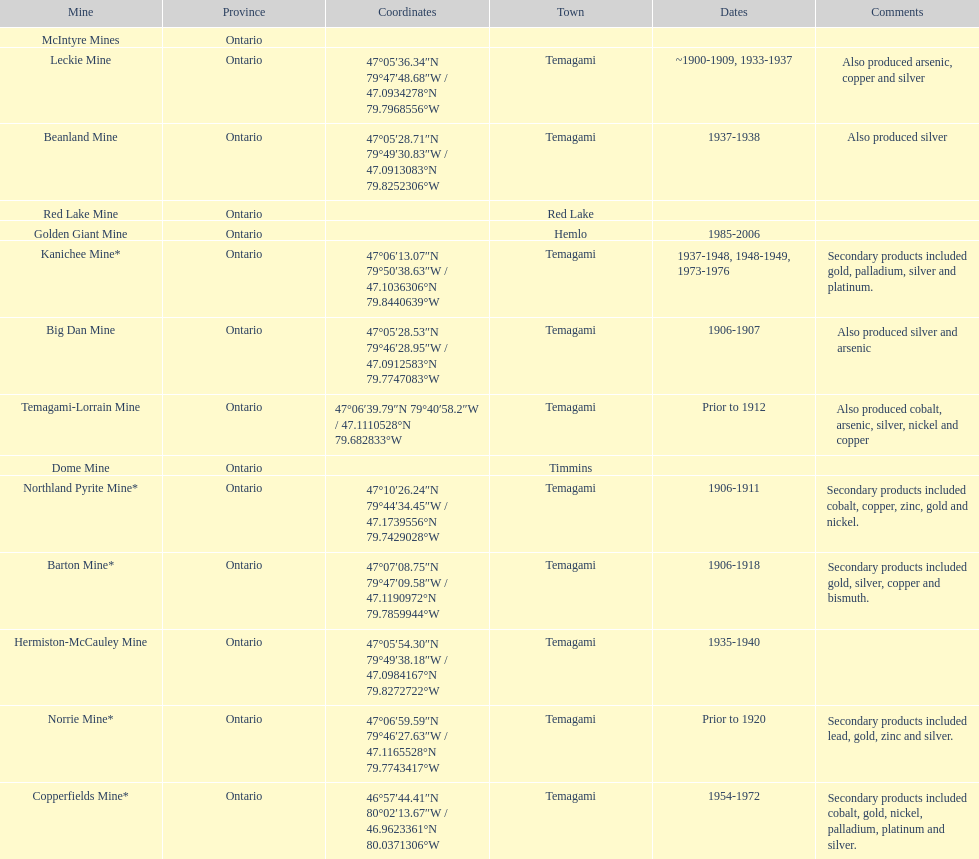How many times is temagami listedon the list? 10. 